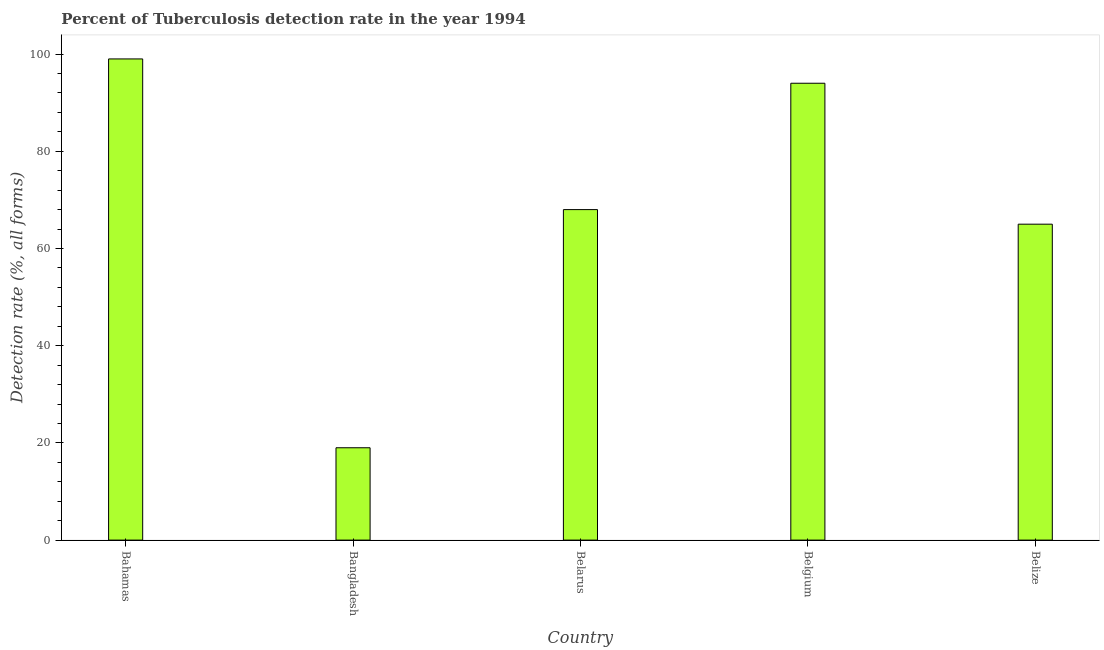Does the graph contain any zero values?
Offer a very short reply. No. What is the title of the graph?
Offer a terse response. Percent of Tuberculosis detection rate in the year 1994. What is the label or title of the X-axis?
Keep it short and to the point. Country. What is the label or title of the Y-axis?
Your answer should be very brief. Detection rate (%, all forms). Across all countries, what is the maximum detection rate of tuberculosis?
Offer a very short reply. 99. In which country was the detection rate of tuberculosis maximum?
Offer a very short reply. Bahamas. What is the sum of the detection rate of tuberculosis?
Ensure brevity in your answer.  345. What is the median detection rate of tuberculosis?
Give a very brief answer. 68. In how many countries, is the detection rate of tuberculosis greater than 28 %?
Offer a terse response. 4. What is the ratio of the detection rate of tuberculosis in Belgium to that in Belize?
Provide a short and direct response. 1.45. Is the difference between the detection rate of tuberculosis in Bangladesh and Belgium greater than the difference between any two countries?
Give a very brief answer. No. Is the sum of the detection rate of tuberculosis in Bahamas and Bangladesh greater than the maximum detection rate of tuberculosis across all countries?
Give a very brief answer. Yes. What is the difference between the highest and the lowest detection rate of tuberculosis?
Provide a short and direct response. 80. Are all the bars in the graph horizontal?
Provide a succinct answer. No. How many countries are there in the graph?
Your answer should be compact. 5. What is the Detection rate (%, all forms) of Bangladesh?
Keep it short and to the point. 19. What is the Detection rate (%, all forms) of Belarus?
Offer a very short reply. 68. What is the Detection rate (%, all forms) in Belgium?
Keep it short and to the point. 94. What is the Detection rate (%, all forms) of Belize?
Your answer should be very brief. 65. What is the difference between the Detection rate (%, all forms) in Bahamas and Bangladesh?
Ensure brevity in your answer.  80. What is the difference between the Detection rate (%, all forms) in Bahamas and Belarus?
Make the answer very short. 31. What is the difference between the Detection rate (%, all forms) in Bahamas and Belgium?
Your response must be concise. 5. What is the difference between the Detection rate (%, all forms) in Bangladesh and Belarus?
Provide a short and direct response. -49. What is the difference between the Detection rate (%, all forms) in Bangladesh and Belgium?
Give a very brief answer. -75. What is the difference between the Detection rate (%, all forms) in Bangladesh and Belize?
Your answer should be very brief. -46. What is the difference between the Detection rate (%, all forms) in Belarus and Belgium?
Offer a very short reply. -26. What is the ratio of the Detection rate (%, all forms) in Bahamas to that in Bangladesh?
Provide a short and direct response. 5.21. What is the ratio of the Detection rate (%, all forms) in Bahamas to that in Belarus?
Your response must be concise. 1.46. What is the ratio of the Detection rate (%, all forms) in Bahamas to that in Belgium?
Your response must be concise. 1.05. What is the ratio of the Detection rate (%, all forms) in Bahamas to that in Belize?
Make the answer very short. 1.52. What is the ratio of the Detection rate (%, all forms) in Bangladesh to that in Belarus?
Offer a very short reply. 0.28. What is the ratio of the Detection rate (%, all forms) in Bangladesh to that in Belgium?
Your answer should be very brief. 0.2. What is the ratio of the Detection rate (%, all forms) in Bangladesh to that in Belize?
Ensure brevity in your answer.  0.29. What is the ratio of the Detection rate (%, all forms) in Belarus to that in Belgium?
Make the answer very short. 0.72. What is the ratio of the Detection rate (%, all forms) in Belarus to that in Belize?
Your answer should be compact. 1.05. What is the ratio of the Detection rate (%, all forms) in Belgium to that in Belize?
Provide a succinct answer. 1.45. 